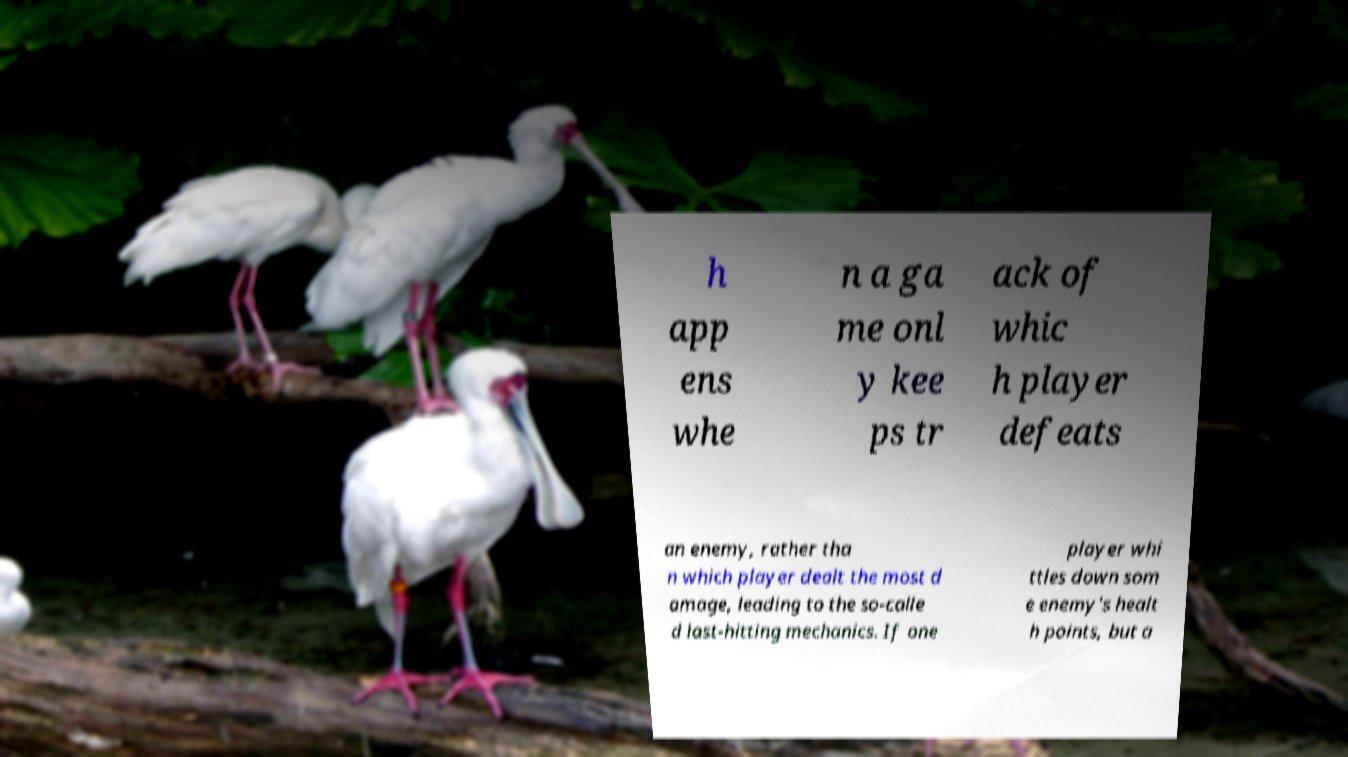Please read and relay the text visible in this image. What does it say? h app ens whe n a ga me onl y kee ps tr ack of whic h player defeats an enemy, rather tha n which player dealt the most d amage, leading to the so-calle d last-hitting mechanics. If one player whi ttles down som e enemy's healt h points, but a 